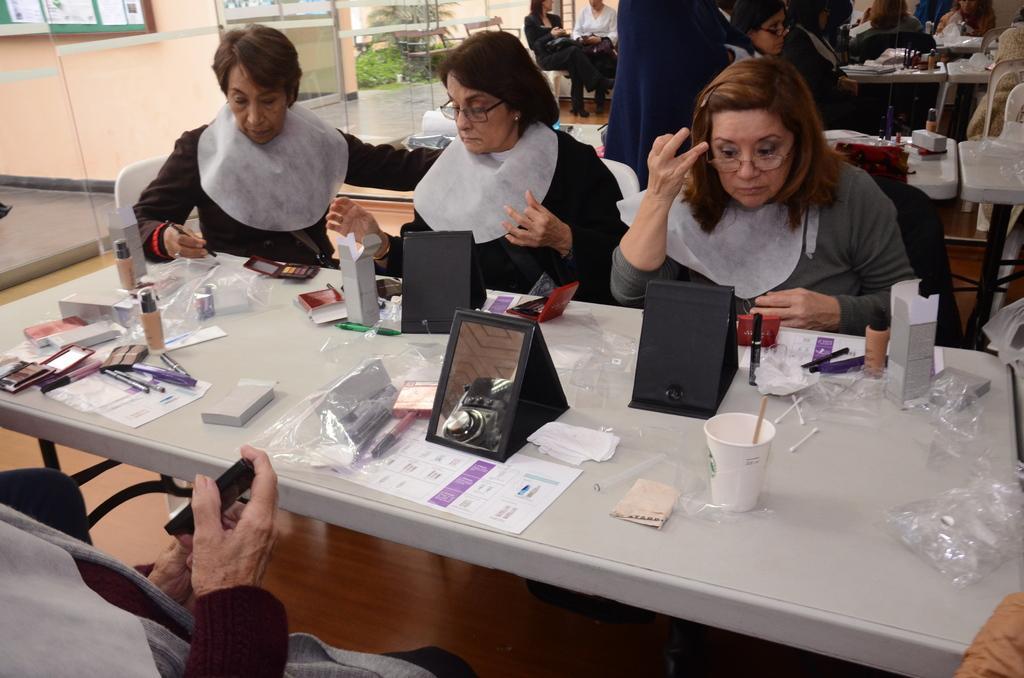In one or two sentences, can you explain what this image depicts? people are sitting on the chairs, across the tables. on a rectangular table there are glass, mirrors, covers, papers and makeup products. 3 people are sitting on the chairs and applying makeup. to their right there is a door door. behind that there are trees. 